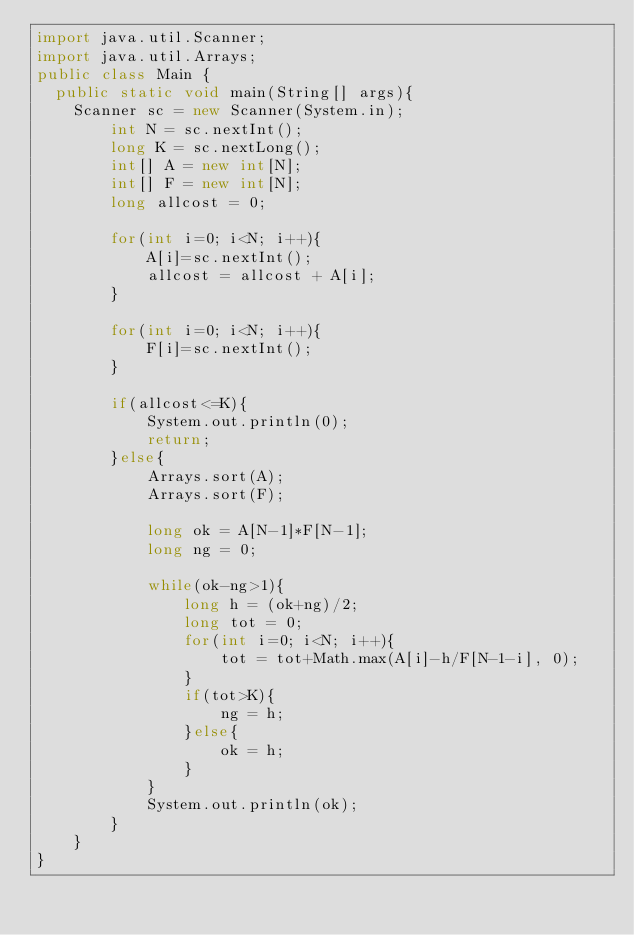<code> <loc_0><loc_0><loc_500><loc_500><_Java_>import java.util.Scanner;
import java.util.Arrays;
public class Main {
	public static void main(String[] args){
		Scanner sc = new Scanner(System.in);
        int N = sc.nextInt();
        long K = sc.nextLong();
        int[] A = new int[N];
        int[] F = new int[N];
        long allcost = 0;

        for(int i=0; i<N; i++){
            A[i]=sc.nextInt();
            allcost = allcost + A[i];
        }

        for(int i=0; i<N; i++){
            F[i]=sc.nextInt();
        }

        if(allcost<=K){
            System.out.println(0);
            return;
        }else{
            Arrays.sort(A);
            Arrays.sort(F);

            long ok = A[N-1]*F[N-1];
            long ng = 0;

            while(ok-ng>1){
                long h = (ok+ng)/2;
                long tot = 0;
                for(int i=0; i<N; i++){
                    tot = tot+Math.max(A[i]-h/F[N-1-i], 0);
                }
                if(tot>K){
                    ng = h;
                }else{
                    ok = h;
                }
            }
            System.out.println(ok);
        }
    }
}</code> 